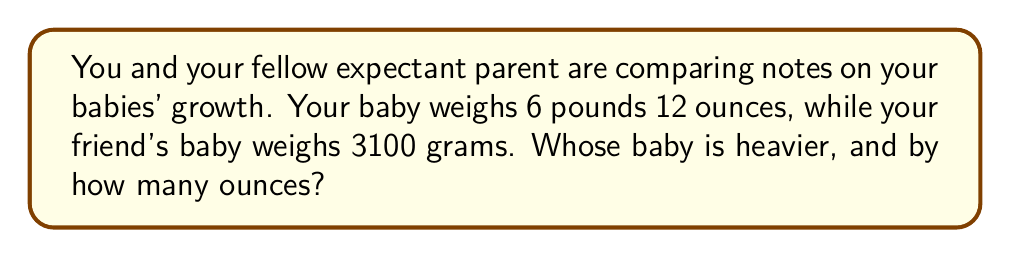Help me with this question. To solve this problem, we need to convert both weights to the same unit. Let's convert both to ounces.

1. Convert your baby's weight to ounces:
   $6$ pounds $12$ ounces = $(6 \times 16) + 12 = 108$ ounces

2. Convert your friend's baby's weight from grams to ounces:
   $1$ ounce $\approx 28.35$ grams
   $3100$ grams $\div 28.35 \approx 109.35$ ounces

3. Compare the weights:
   Your friend's baby: $109.35$ ounces
   Your baby: $108$ ounces

4. Calculate the difference:
   $109.35 - 108 = 1.35$ ounces

Therefore, your friend's baby is heavier by approximately $1.35$ ounces.
Answer: Your friend's baby is heavier by approximately $1.35$ ounces. 